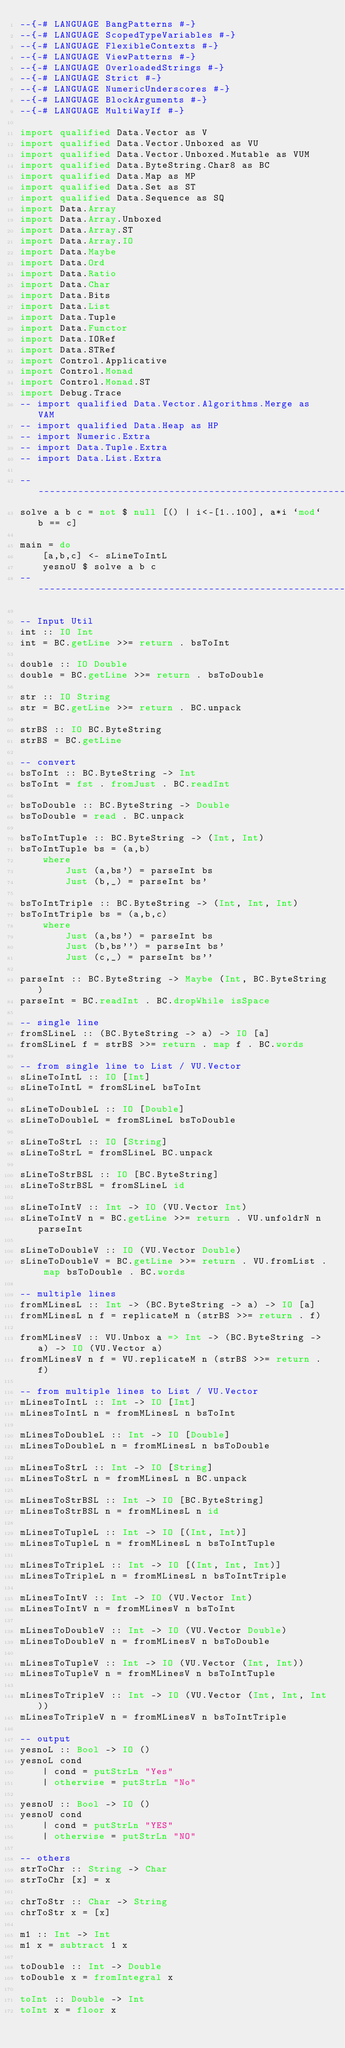Convert code to text. <code><loc_0><loc_0><loc_500><loc_500><_Haskell_>--{-# LANGUAGE BangPatterns #-}
--{-# LANGUAGE ScopedTypeVariables #-}
--{-# LANGUAGE FlexibleContexts #-}
--{-# LANGUAGE ViewPatterns #-}
--{-# LANGUAGE OverloadedStrings #-}
--{-# LANGUAGE Strict #-}
--{-# LANGUAGE NumericUnderscores #-}
--{-# LANGUAGE BlockArguments #-}
--{-# LANGUAGE MultiWayIf #-}

import qualified Data.Vector as V
import qualified Data.Vector.Unboxed as VU
import qualified Data.Vector.Unboxed.Mutable as VUM
import qualified Data.ByteString.Char8 as BC
import qualified Data.Map as MP
import qualified Data.Set as ST
import qualified Data.Sequence as SQ
import Data.Array
import Data.Array.Unboxed
import Data.Array.ST
import Data.Array.IO
import Data.Maybe
import Data.Ord
import Data.Ratio
import Data.Char
import Data.Bits
import Data.List
import Data.Tuple
import Data.Functor
import Data.IORef
import Data.STRef
import Control.Applicative
import Control.Monad
import Control.Monad.ST
import Debug.Trace
-- import qualified Data.Vector.Algorithms.Merge as VAM
-- import qualified Data.Heap as HP
-- import Numeric.Extra
-- import Data.Tuple.Extra
-- import Data.List.Extra

--------------------------------------------------------------------------
solve a b c = not $ null [() | i<-[1..100], a*i `mod` b == c]

main = do
    [a,b,c] <- sLineToIntL
    yesnoU $ solve a b c
--------------------------------------------------------------------------

-- Input Util
int :: IO Int
int = BC.getLine >>= return . bsToInt

double :: IO Double
double = BC.getLine >>= return . bsToDouble

str :: IO String
str = BC.getLine >>= return . BC.unpack

strBS :: IO BC.ByteString
strBS = BC.getLine

-- convert
bsToInt :: BC.ByteString -> Int
bsToInt = fst . fromJust . BC.readInt

bsToDouble :: BC.ByteString -> Double
bsToDouble = read . BC.unpack

bsToIntTuple :: BC.ByteString -> (Int, Int)
bsToIntTuple bs = (a,b)
    where
        Just (a,bs') = parseInt bs
        Just (b,_) = parseInt bs'

bsToIntTriple :: BC.ByteString -> (Int, Int, Int)
bsToIntTriple bs = (a,b,c)
    where
        Just (a,bs') = parseInt bs
        Just (b,bs'') = parseInt bs'
        Just (c,_) = parseInt bs''

parseInt :: BC.ByteString -> Maybe (Int, BC.ByteString)
parseInt = BC.readInt . BC.dropWhile isSpace

-- single line
fromSLineL :: (BC.ByteString -> a) -> IO [a]
fromSLineL f = strBS >>= return . map f . BC.words

-- from single line to List / VU.Vector 
sLineToIntL :: IO [Int]
sLineToIntL = fromSLineL bsToInt

sLineToDoubleL :: IO [Double]
sLineToDoubleL = fromSLineL bsToDouble

sLineToStrL :: IO [String]
sLineToStrL = fromSLineL BC.unpack

sLineToStrBSL :: IO [BC.ByteString]
sLineToStrBSL = fromSLineL id 

sLineToIntV :: Int -> IO (VU.Vector Int)
sLineToIntV n = BC.getLine >>= return . VU.unfoldrN n parseInt

sLineToDoubleV :: IO (VU.Vector Double)
sLineToDoubleV = BC.getLine >>= return . VU.fromList . map bsToDouble . BC.words

-- multiple lines
fromMLinesL :: Int -> (BC.ByteString -> a) -> IO [a]
fromMLinesL n f = replicateM n (strBS >>= return . f)

fromMLinesV :: VU.Unbox a => Int -> (BC.ByteString -> a) -> IO (VU.Vector a)
fromMLinesV n f = VU.replicateM n (strBS >>= return . f)

-- from multiple lines to List / VU.Vector
mLinesToIntL :: Int -> IO [Int]
mLinesToIntL n = fromMLinesL n bsToInt

mLinesToDoubleL :: Int -> IO [Double]
mLinesToDoubleL n = fromMLinesL n bsToDouble

mLinesToStrL :: Int -> IO [String]
mLinesToStrL n = fromMLinesL n BC.unpack

mLinesToStrBSL :: Int -> IO [BC.ByteString]
mLinesToStrBSL n = fromMLinesL n id

mLinesToTupleL :: Int -> IO [(Int, Int)]
mLinesToTupleL n = fromMLinesL n bsToIntTuple

mLinesToTripleL :: Int -> IO [(Int, Int, Int)]
mLinesToTripleL n = fromMLinesL n bsToIntTriple

mLinesToIntV :: Int -> IO (VU.Vector Int)
mLinesToIntV n = fromMLinesV n bsToInt

mLinesToDoubleV :: Int -> IO (VU.Vector Double)
mLinesToDoubleV n = fromMLinesV n bsToDouble

mLinesToTupleV :: Int -> IO (VU.Vector (Int, Int))
mLinesToTupleV n = fromMLinesV n bsToIntTuple
    
mLinesToTripleV :: Int -> IO (VU.Vector (Int, Int, Int))
mLinesToTripleV n = fromMLinesV n bsToIntTriple

-- output
yesnoL :: Bool -> IO ()
yesnoL cond
    | cond = putStrLn "Yes"
    | otherwise = putStrLn "No"

yesnoU :: Bool -> IO ()
yesnoU cond
    | cond = putStrLn "YES"
    | otherwise = putStrLn "NO"

-- others
strToChr :: String -> Char
strToChr [x] = x

chrToStr :: Char -> String
chrToStr x = [x]

m1 :: Int -> Int
m1 x = subtract 1 x

toDouble :: Int -> Double
toDouble x = fromIntegral x

toInt :: Double -> Int
toInt x = floor x
</code> 